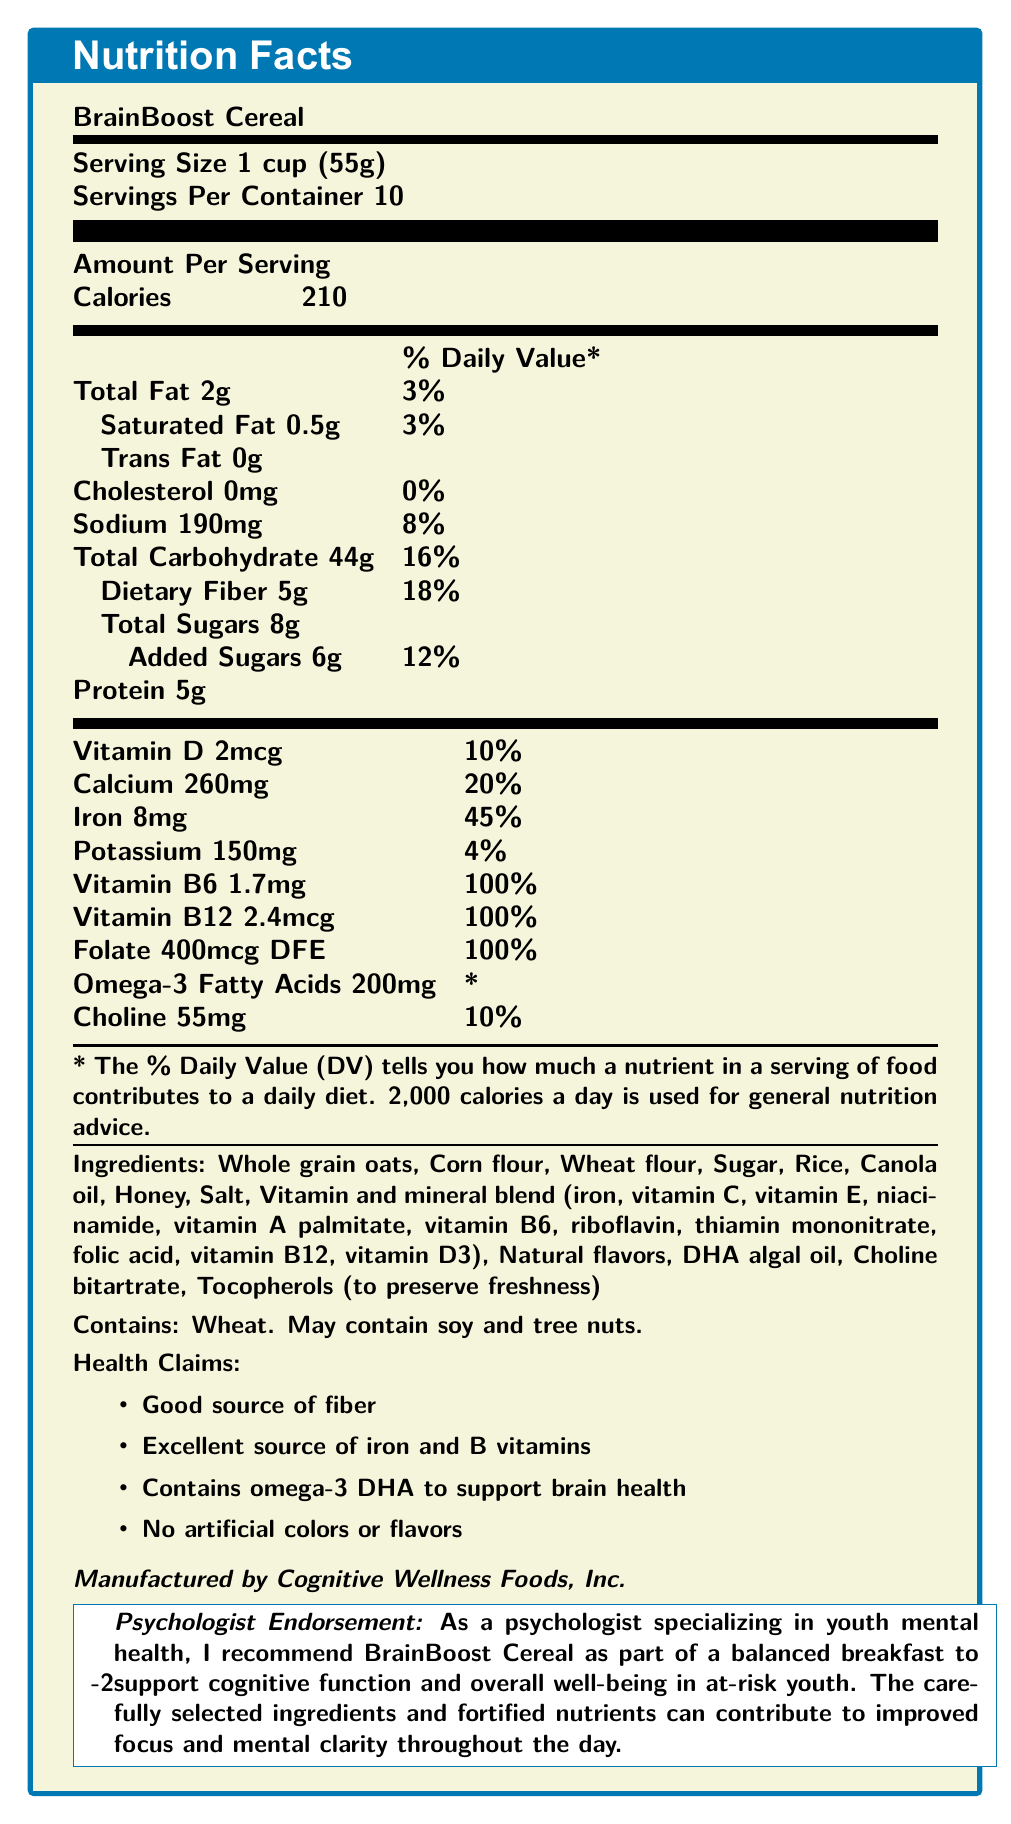what is the serving size of BrainBoost Cereal? The document states that the serving size is 1 cup (55g).
Answer: 1 cup (55g) how many servings per container are listed? The document specifies that there are 10 servings per container.
Answer: 10 how much dietary fiber does one serving contain? The document mentions that one serving contains 5g of dietary fiber.
Answer: 5g what percentage of the Daily Value for iron does one serving provide? The document states that one serving provides 45% of the Daily Value for iron.
Answer: 45% what is the total amount of sugars in one serving, including added sugars? The document lists 8g of total sugars, which includes 6g of added sugars.
Answer: 8g which nutrients are listed to support brain health? A. Vitamin C B. Omega-3 DHA C. Protein D. Calcium The document mentions "Contains omega-3 DHA to support brain health" under health claims.
Answer: B. Omega-3 DHA how many calories are in one serving of BrainBoost Cereal? The document states that there are 210 calories per serving.
Answer: 210 true or false: BrainBoost Cereal contains artificial colors or flavors. The document's health claims state "No artificial colors or flavors."
Answer: False how much vitamin B12 does one serving contain? The document lists that one serving contains 2.4mcg of vitamin B12.
Answer: 2.4mcg what are the primary ingredients in BrainBoost Cereal? These ingredients are listed in the document under the ingredients section.
Answer: Whole grain oats, Corn flour, Wheat flour, Sugar, Rice, Canola oil, Honey, Salt, Vitamin and mineral blend, etc. what is the main idea of the document? The document details the nutritional values, serving size, health claims, and ingredients to emphasize the cereal's benefits for cognitive health.
Answer: The document presents the nutrition facts, ingredients, and health benefits of BrainBoost Cereal. It highlights its suitability for supporting cognitive function and overall well-being in at-risk youth with its nutrient-rich profile. how much choline does one serving of BrainBoost Cereal contain? The document states that one serving contains 55mg of choline.
Answer: 55mg who manufactures BrainBoost Cereal? The document specifies that BrainBoost Cereal is manufactured by Cognitive Wellness Foods, Inc.
Answer: Cognitive Wellness Foods, Inc. which nutrient is not listed in the vitamin and mineral blend? A. Iron B. Vitamin C C. Potassium D. Folic Acid The document lists iron, vitamin C, and folic acid as part of the vitamin and mineral blend, but potassium is not included in this blend.
Answer: C. Potassium does BrainBoost Cereal contain soy ingredients? The document states under allergen info that it may contain soy.
Answer: May contain soy how much saturated fat is in one serving? The document lists that one serving contains 0.5g of saturated fat.
Answer: 0.5g which of the following health claims are made about BrainBoost Cereal? A. Contains preservatives B. Good source of fiber C. Excellent source of iron D. Promotes weight loss The document lists "Good source of fiber" and "Excellent source of iron and B vitamins" under health claims.
Answer: Options B and C only what percentage of the Daily Value does 190mg of sodium represent? The document states that 190mg of sodium represents 8% of the Daily Value.
Answer: 8% what is the psychologist's endorsement for BrainBoost Cereal? The psychologist's endorsement is explicitly stated at the end of the document.
Answer: The psychologist recommends BrainBoost Cereal as part of a balanced breakfast to support cognitive function and overall well-being in at-risk youth. which ingredient in BrainBoost Cereal is used to preserve freshness? The document lists tocopherols under the ingredients, noting that they are used to preserve freshness.
Answer: Tocopherols what are the health benefits of BrainBoost Cereal for cognitive functions? These nutrients are highlighted in the health claims and the psychologist's endorsement.
Answer: It contains nutrients like iron, B vitamins, omega-3 fatty acids, and choline that support brain health and cognitive functions. what is the cost per container of BrainBoost Cereal? The document does not provide any information about the cost per container.
Answer: Cannot be determined 